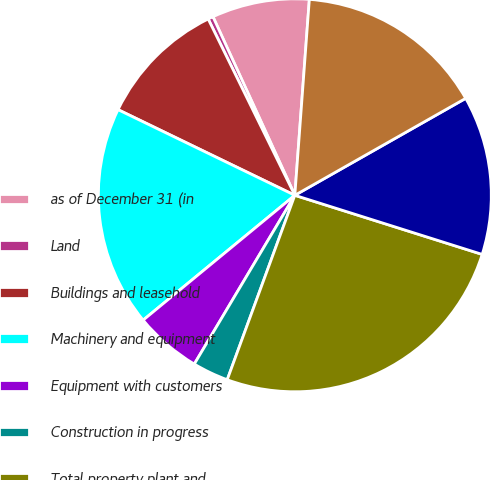Convert chart. <chart><loc_0><loc_0><loc_500><loc_500><pie_chart><fcel>as of December 31 (in<fcel>Land<fcel>Buildings and leasehold<fcel>Machinery and equipment<fcel>Equipment with customers<fcel>Construction in progress<fcel>Total property plant and<fcel>Accumulated depreciation and<fcel>Property plant and equipment<nl><fcel>8.02%<fcel>0.43%<fcel>10.55%<fcel>18.14%<fcel>5.49%<fcel>2.96%<fcel>25.73%<fcel>13.08%<fcel>15.61%<nl></chart> 